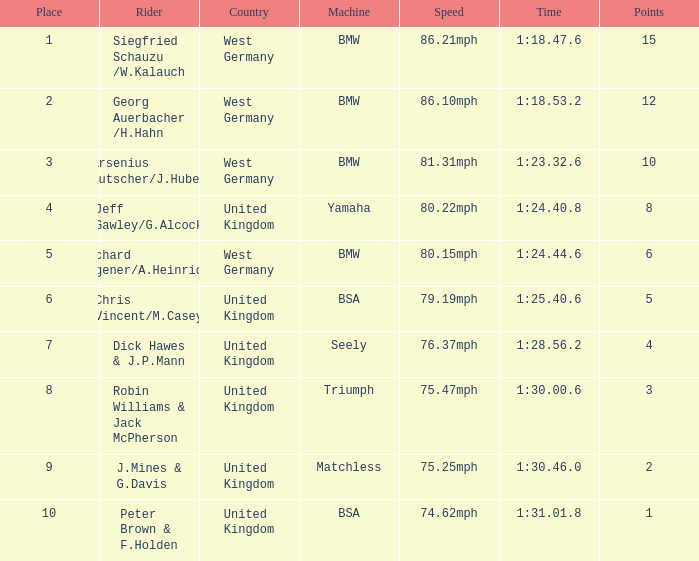6? 1.0. 